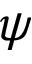<formula> <loc_0><loc_0><loc_500><loc_500>\psi</formula> 